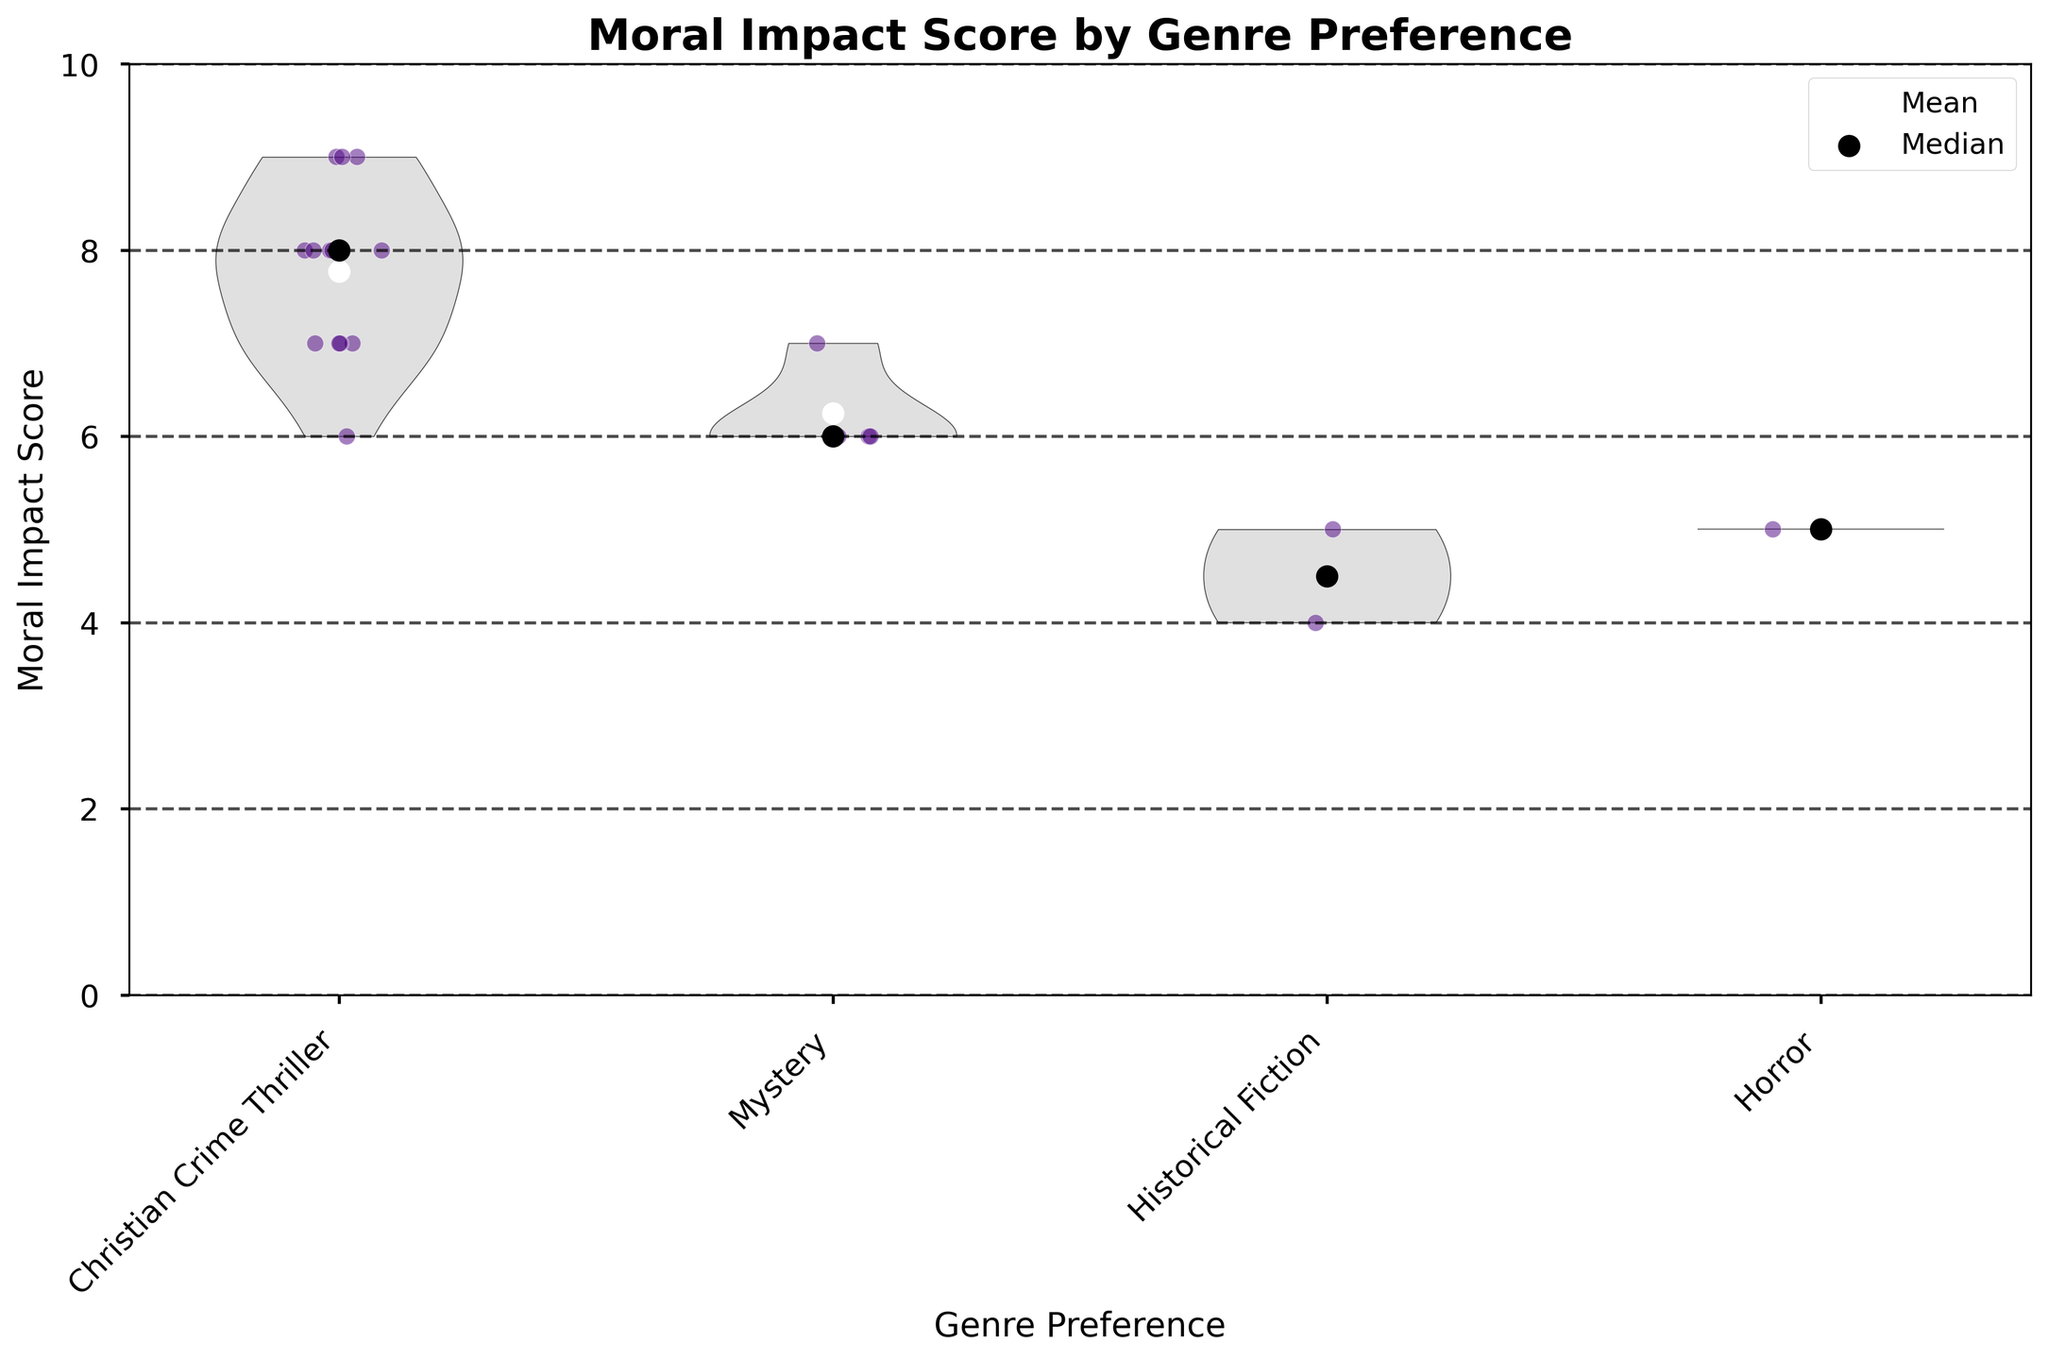What's the title of the chart? The title of the chart is displayed at the top, and it reads "Moral Impact Score by Genre Preference."
Answer: Moral Impact Score by Genre Preference What does the y-axis represent? The y-axis is labeled "Moral Impact Score," which represents the perceived moral impact score given by survey respondents.
Answer: Moral Impact Score Which genre has the highest median moral impact score? The median score is shown by the black dots on the plot. By comparing the medians visually, "Christian Crime Thriller" appears to have the highest median score.
Answer: Christian Crime Thriller How many genre preferences are displayed on the x-axis? By counting the number of different labels on the x-axis, we can see there are five genres: "Christian Crime Thriller," "Mystery," "Historical Fiction," and "Horror."
Answer: Four Which genre has the highest mean moral impact score? The mean score is shown by the white dots on the plot. By comparing the means visually, "Christian Crime Thriller" has the highest mean score.
Answer: Christian Crime Thriller What is the color of the jittered points in the chart? The jittered points in the chart are colored deep purple with white edges.
Answer: Deep purple Is there any genre where the data points show a considerable spread in moral impact scores? By examining the spread of the jittered points, "Christian Crime Thriller" shows a considerable spread from about 6 to 9.
Answer: Christian Crime Thriller Which genre has the lowest maximum moral impact score among the samples? By examining the upper tails of the violins, "Historical Fiction" seems to have the lowest maximum, ending at around 5.
Answer: Historical Fiction Compare the mean moral impact scores for "Mystery" and "Horror." Which is higher? The mean score is shown as white dots. By comparing these, the "Mystery" genre has a higher mean score than "Horror."
Answer: Mystery How do the moral impact scores for "Christian Crime Thriller" compare across different demographics like age and gender? From the jittered points within the "Christian Crime Thriller" violin, we can see they are scattered across different ages and genders, indicating diverse responses without a clear trend for these demographics in the current plot.
Answer: Diverse responses 